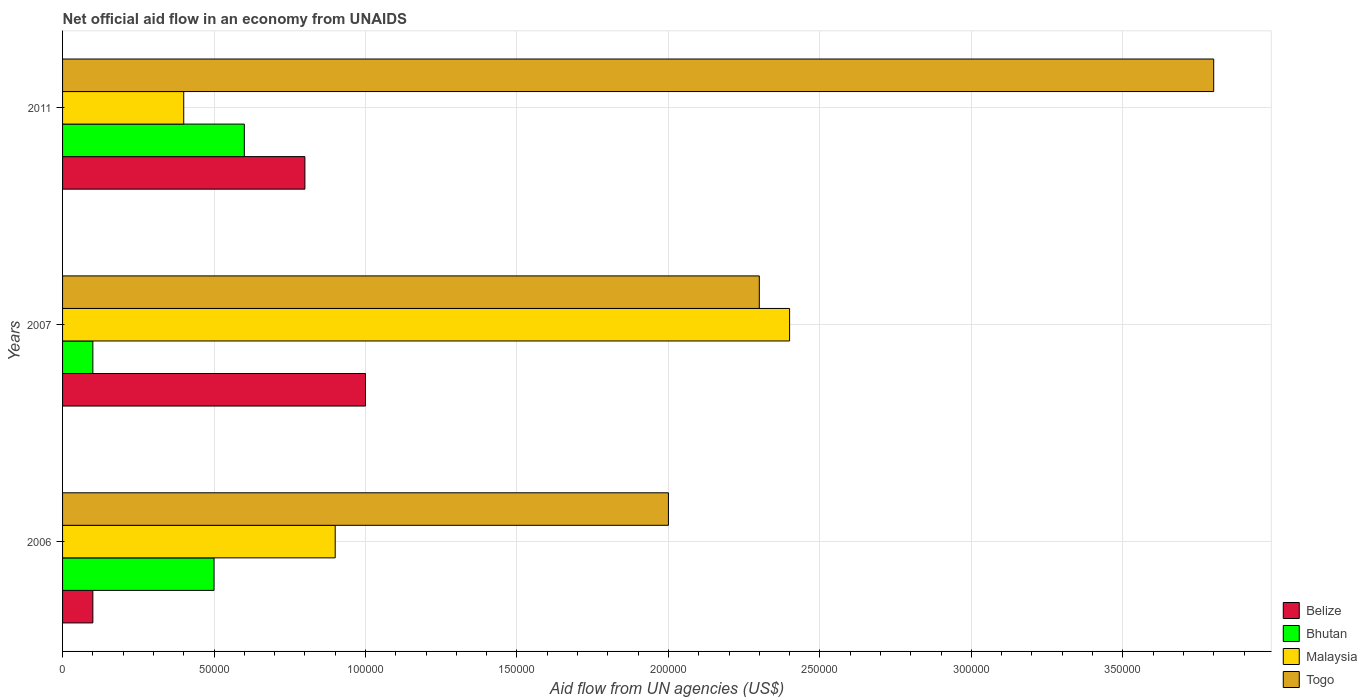How many different coloured bars are there?
Make the answer very short. 4. How many groups of bars are there?
Your response must be concise. 3. Are the number of bars per tick equal to the number of legend labels?
Your response must be concise. Yes. How many bars are there on the 1st tick from the bottom?
Provide a succinct answer. 4. What is the label of the 1st group of bars from the top?
Give a very brief answer. 2011. In how many cases, is the number of bars for a given year not equal to the number of legend labels?
Provide a short and direct response. 0. What is the net official aid flow in Belize in 2007?
Offer a terse response. 1.00e+05. Across all years, what is the maximum net official aid flow in Togo?
Provide a succinct answer. 3.80e+05. Across all years, what is the minimum net official aid flow in Malaysia?
Keep it short and to the point. 4.00e+04. In which year was the net official aid flow in Belize maximum?
Provide a short and direct response. 2007. In which year was the net official aid flow in Bhutan minimum?
Give a very brief answer. 2007. What is the difference between the net official aid flow in Belize in 2006 and that in 2007?
Make the answer very short. -9.00e+04. What is the difference between the net official aid flow in Togo in 2006 and the net official aid flow in Bhutan in 2011?
Give a very brief answer. 1.40e+05. What is the average net official aid flow in Malaysia per year?
Keep it short and to the point. 1.23e+05. In the year 2006, what is the difference between the net official aid flow in Togo and net official aid flow in Belize?
Make the answer very short. 1.90e+05. What is the ratio of the net official aid flow in Malaysia in 2007 to that in 2011?
Your response must be concise. 6. Is the difference between the net official aid flow in Togo in 2007 and 2011 greater than the difference between the net official aid flow in Belize in 2007 and 2011?
Give a very brief answer. No. What is the difference between the highest and the second highest net official aid flow in Bhutan?
Your response must be concise. 10000. What is the difference between the highest and the lowest net official aid flow in Togo?
Offer a very short reply. 1.80e+05. In how many years, is the net official aid flow in Togo greater than the average net official aid flow in Togo taken over all years?
Your answer should be compact. 1. What does the 2nd bar from the top in 2006 represents?
Provide a succinct answer. Malaysia. What does the 3rd bar from the bottom in 2006 represents?
Provide a succinct answer. Malaysia. Is it the case that in every year, the sum of the net official aid flow in Bhutan and net official aid flow in Togo is greater than the net official aid flow in Belize?
Make the answer very short. Yes. Are all the bars in the graph horizontal?
Make the answer very short. Yes. How many years are there in the graph?
Offer a very short reply. 3. What is the difference between two consecutive major ticks on the X-axis?
Your response must be concise. 5.00e+04. Are the values on the major ticks of X-axis written in scientific E-notation?
Offer a very short reply. No. Does the graph contain any zero values?
Your response must be concise. No. Does the graph contain grids?
Provide a succinct answer. Yes. Where does the legend appear in the graph?
Make the answer very short. Bottom right. How many legend labels are there?
Your answer should be compact. 4. How are the legend labels stacked?
Keep it short and to the point. Vertical. What is the title of the graph?
Offer a very short reply. Net official aid flow in an economy from UNAIDS. What is the label or title of the X-axis?
Provide a short and direct response. Aid flow from UN agencies (US$). What is the label or title of the Y-axis?
Your response must be concise. Years. What is the Aid flow from UN agencies (US$) of Belize in 2006?
Your response must be concise. 10000. What is the Aid flow from UN agencies (US$) in Malaysia in 2006?
Keep it short and to the point. 9.00e+04. What is the Aid flow from UN agencies (US$) in Togo in 2006?
Offer a very short reply. 2.00e+05. What is the Aid flow from UN agencies (US$) of Belize in 2007?
Your response must be concise. 1.00e+05. What is the Aid flow from UN agencies (US$) of Bhutan in 2007?
Offer a terse response. 10000. What is the Aid flow from UN agencies (US$) of Malaysia in 2007?
Your answer should be compact. 2.40e+05. What is the Aid flow from UN agencies (US$) of Belize in 2011?
Give a very brief answer. 8.00e+04. What is the Aid flow from UN agencies (US$) of Malaysia in 2011?
Make the answer very short. 4.00e+04. What is the Aid flow from UN agencies (US$) in Togo in 2011?
Your answer should be compact. 3.80e+05. Across all years, what is the minimum Aid flow from UN agencies (US$) of Togo?
Your answer should be compact. 2.00e+05. What is the total Aid flow from UN agencies (US$) of Belize in the graph?
Your answer should be compact. 1.90e+05. What is the total Aid flow from UN agencies (US$) in Bhutan in the graph?
Offer a very short reply. 1.20e+05. What is the total Aid flow from UN agencies (US$) in Togo in the graph?
Provide a succinct answer. 8.10e+05. What is the difference between the Aid flow from UN agencies (US$) in Belize in 2006 and that in 2007?
Provide a succinct answer. -9.00e+04. What is the difference between the Aid flow from UN agencies (US$) in Togo in 2006 and that in 2007?
Your answer should be compact. -3.00e+04. What is the difference between the Aid flow from UN agencies (US$) in Bhutan in 2006 and that in 2011?
Provide a short and direct response. -10000. What is the difference between the Aid flow from UN agencies (US$) in Malaysia in 2006 and that in 2011?
Offer a very short reply. 5.00e+04. What is the difference between the Aid flow from UN agencies (US$) in Belize in 2007 and that in 2011?
Your response must be concise. 2.00e+04. What is the difference between the Aid flow from UN agencies (US$) in Bhutan in 2007 and that in 2011?
Offer a terse response. -5.00e+04. What is the difference between the Aid flow from UN agencies (US$) of Belize in 2006 and the Aid flow from UN agencies (US$) of Togo in 2007?
Offer a very short reply. -2.20e+05. What is the difference between the Aid flow from UN agencies (US$) of Bhutan in 2006 and the Aid flow from UN agencies (US$) of Malaysia in 2007?
Ensure brevity in your answer.  -1.90e+05. What is the difference between the Aid flow from UN agencies (US$) of Bhutan in 2006 and the Aid flow from UN agencies (US$) of Togo in 2007?
Provide a succinct answer. -1.80e+05. What is the difference between the Aid flow from UN agencies (US$) in Belize in 2006 and the Aid flow from UN agencies (US$) in Togo in 2011?
Offer a terse response. -3.70e+05. What is the difference between the Aid flow from UN agencies (US$) of Bhutan in 2006 and the Aid flow from UN agencies (US$) of Malaysia in 2011?
Offer a terse response. 10000. What is the difference between the Aid flow from UN agencies (US$) in Bhutan in 2006 and the Aid flow from UN agencies (US$) in Togo in 2011?
Make the answer very short. -3.30e+05. What is the difference between the Aid flow from UN agencies (US$) of Belize in 2007 and the Aid flow from UN agencies (US$) of Malaysia in 2011?
Your response must be concise. 6.00e+04. What is the difference between the Aid flow from UN agencies (US$) in Belize in 2007 and the Aid flow from UN agencies (US$) in Togo in 2011?
Keep it short and to the point. -2.80e+05. What is the difference between the Aid flow from UN agencies (US$) of Bhutan in 2007 and the Aid flow from UN agencies (US$) of Togo in 2011?
Your answer should be compact. -3.70e+05. What is the average Aid flow from UN agencies (US$) of Belize per year?
Make the answer very short. 6.33e+04. What is the average Aid flow from UN agencies (US$) of Malaysia per year?
Your answer should be very brief. 1.23e+05. What is the average Aid flow from UN agencies (US$) in Togo per year?
Give a very brief answer. 2.70e+05. In the year 2006, what is the difference between the Aid flow from UN agencies (US$) in Bhutan and Aid flow from UN agencies (US$) in Togo?
Keep it short and to the point. -1.50e+05. In the year 2006, what is the difference between the Aid flow from UN agencies (US$) of Malaysia and Aid flow from UN agencies (US$) of Togo?
Make the answer very short. -1.10e+05. In the year 2007, what is the difference between the Aid flow from UN agencies (US$) of Bhutan and Aid flow from UN agencies (US$) of Malaysia?
Give a very brief answer. -2.30e+05. In the year 2011, what is the difference between the Aid flow from UN agencies (US$) of Belize and Aid flow from UN agencies (US$) of Bhutan?
Keep it short and to the point. 2.00e+04. In the year 2011, what is the difference between the Aid flow from UN agencies (US$) of Belize and Aid flow from UN agencies (US$) of Malaysia?
Offer a terse response. 4.00e+04. In the year 2011, what is the difference between the Aid flow from UN agencies (US$) in Bhutan and Aid flow from UN agencies (US$) in Malaysia?
Ensure brevity in your answer.  2.00e+04. In the year 2011, what is the difference between the Aid flow from UN agencies (US$) of Bhutan and Aid flow from UN agencies (US$) of Togo?
Your answer should be compact. -3.20e+05. What is the ratio of the Aid flow from UN agencies (US$) in Bhutan in 2006 to that in 2007?
Offer a very short reply. 5. What is the ratio of the Aid flow from UN agencies (US$) in Togo in 2006 to that in 2007?
Your response must be concise. 0.87. What is the ratio of the Aid flow from UN agencies (US$) of Belize in 2006 to that in 2011?
Provide a succinct answer. 0.12. What is the ratio of the Aid flow from UN agencies (US$) of Malaysia in 2006 to that in 2011?
Give a very brief answer. 2.25. What is the ratio of the Aid flow from UN agencies (US$) in Togo in 2006 to that in 2011?
Your answer should be very brief. 0.53. What is the ratio of the Aid flow from UN agencies (US$) of Togo in 2007 to that in 2011?
Your answer should be very brief. 0.61. What is the difference between the highest and the second highest Aid flow from UN agencies (US$) of Belize?
Make the answer very short. 2.00e+04. What is the difference between the highest and the second highest Aid flow from UN agencies (US$) of Bhutan?
Ensure brevity in your answer.  10000. What is the difference between the highest and the second highest Aid flow from UN agencies (US$) of Malaysia?
Make the answer very short. 1.50e+05. What is the difference between the highest and the second highest Aid flow from UN agencies (US$) in Togo?
Make the answer very short. 1.50e+05. What is the difference between the highest and the lowest Aid flow from UN agencies (US$) of Bhutan?
Ensure brevity in your answer.  5.00e+04. 